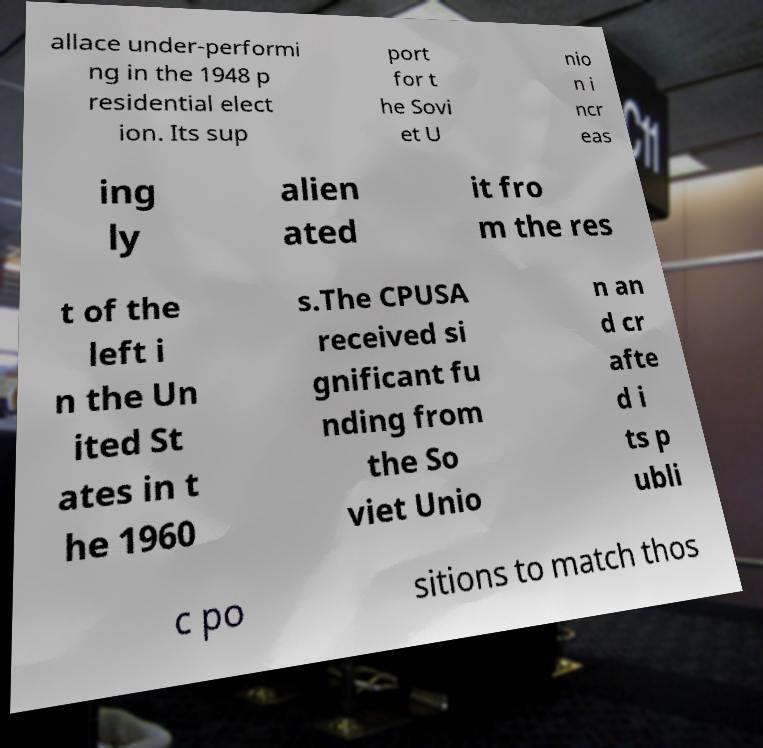Please identify and transcribe the text found in this image. allace under-performi ng in the 1948 p residential elect ion. Its sup port for t he Sovi et U nio n i ncr eas ing ly alien ated it fro m the res t of the left i n the Un ited St ates in t he 1960 s.The CPUSA received si gnificant fu nding from the So viet Unio n an d cr afte d i ts p ubli c po sitions to match thos 